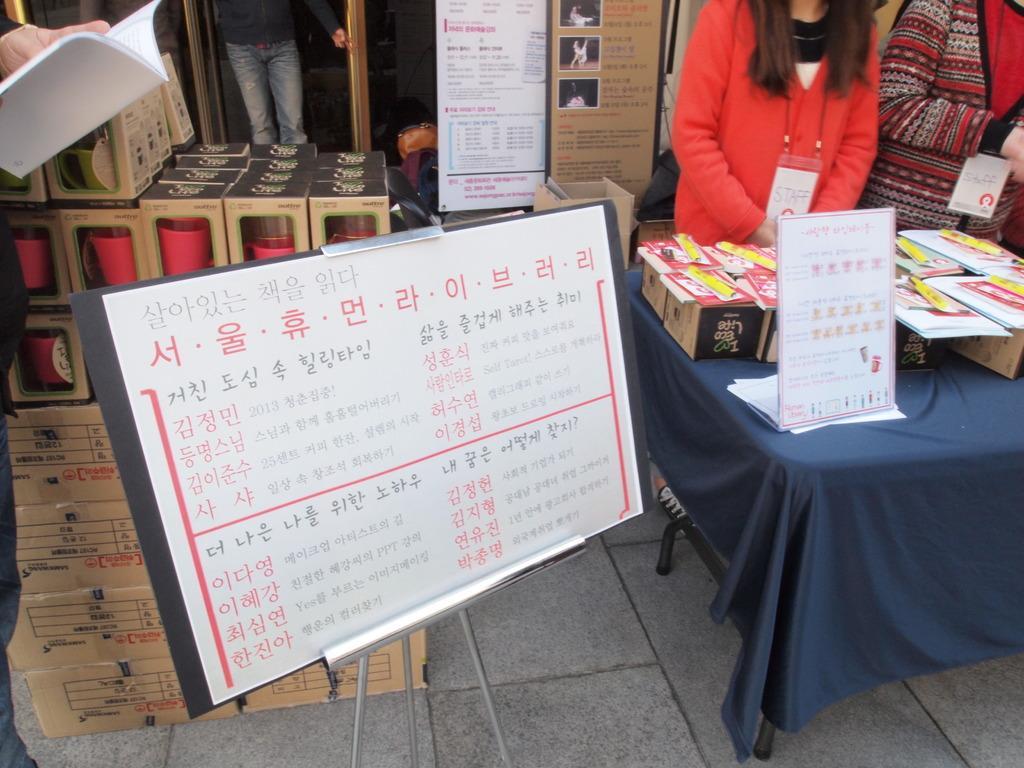Could you give a brief overview of what you see in this image? In this image, at the right side there is a table, on that table there is a white color poster and there are some boxes on the table, at the left side there is a white color poster and there are some carton boxes, there are some people standing. 